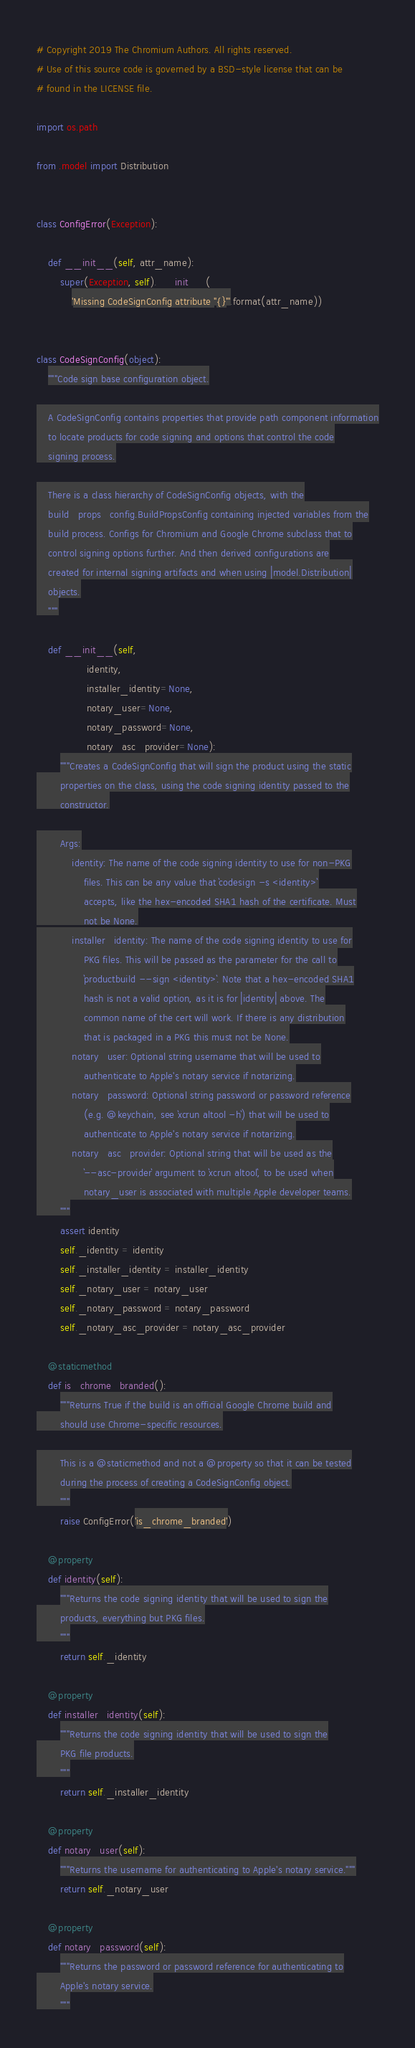Convert code to text. <code><loc_0><loc_0><loc_500><loc_500><_Python_># Copyright 2019 The Chromium Authors. All rights reserved.
# Use of this source code is governed by a BSD-style license that can be
# found in the LICENSE file.

import os.path

from .model import Distribution


class ConfigError(Exception):

    def __init__(self, attr_name):
        super(Exception, self).__init__(
            'Missing CodeSignConfig attribute "{}"'.format(attr_name))


class CodeSignConfig(object):
    """Code sign base configuration object.

    A CodeSignConfig contains properties that provide path component information
    to locate products for code signing and options that control the code
    signing process.

    There is a class hierarchy of CodeSignConfig objects, with the
    build_props_config.BuildPropsConfig containing injected variables from the
    build process. Configs for Chromium and Google Chrome subclass that to
    control signing options further. And then derived configurations are
    created for internal signing artifacts and when using |model.Distribution|
    objects.
    """

    def __init__(self,
                 identity,
                 installer_identity=None,
                 notary_user=None,
                 notary_password=None,
                 notary_asc_provider=None):
        """Creates a CodeSignConfig that will sign the product using the static
        properties on the class, using the code signing identity passed to the
        constructor.

        Args:
            identity: The name of the code signing identity to use for non-PKG
                files. This can be any value that `codesign -s <identity>`
                accepts, like the hex-encoded SHA1 hash of the certificate. Must
                not be None.
            installer_identity: The name of the code signing identity to use for
                PKG files. This will be passed as the parameter for the call to
                `productbuild --sign <identity>`. Note that a hex-encoded SHA1
                hash is not a valid option, as it is for |identity| above. The
                common name of the cert will work. If there is any distribution
                that is packaged in a PKG this must not be None.
            notary_user: Optional string username that will be used to
                authenticate to Apple's notary service if notarizing.
            notary_password: Optional string password or password reference
                (e.g. @keychain, see `xcrun altool -h`) that will be used to
                authenticate to Apple's notary service if notarizing.
            notary_asc_provider: Optional string that will be used as the
                `--asc-provider` argument to `xcrun altool`, to be used when
                notary_user is associated with multiple Apple developer teams.
        """
        assert identity
        self._identity = identity
        self._installer_identity = installer_identity
        self._notary_user = notary_user
        self._notary_password = notary_password
        self._notary_asc_provider = notary_asc_provider

    @staticmethod
    def is_chrome_branded():
        """Returns True if the build is an official Google Chrome build and
        should use Chrome-specific resources.

        This is a @staticmethod and not a @property so that it can be tested
        during the process of creating a CodeSignConfig object.
        """
        raise ConfigError('is_chrome_branded')

    @property
    def identity(self):
        """Returns the code signing identity that will be used to sign the
        products, everything but PKG files.
        """
        return self._identity

    @property
    def installer_identity(self):
        """Returns the code signing identity that will be used to sign the
        PKG file products.
        """
        return self._installer_identity

    @property
    def notary_user(self):
        """Returns the username for authenticating to Apple's notary service."""
        return self._notary_user

    @property
    def notary_password(self):
        """Returns the password or password reference for authenticating to
        Apple's notary service.
        """</code> 